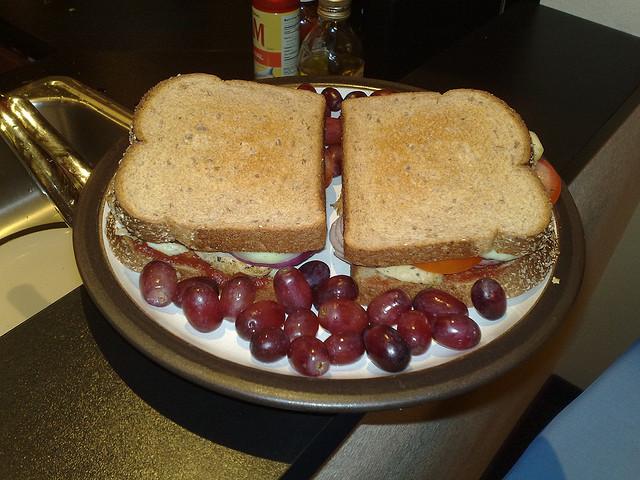Is this sandwich vegetarian?
Give a very brief answer. Yes. Could the bread have been home-made?
Quick response, please. No. Is the bread toasted?
Short answer required. Yes. Is there cheese on the sandwich?
Give a very brief answer. Yes. What is the yellow and red container in the background used for?
Answer briefly. Pam. 